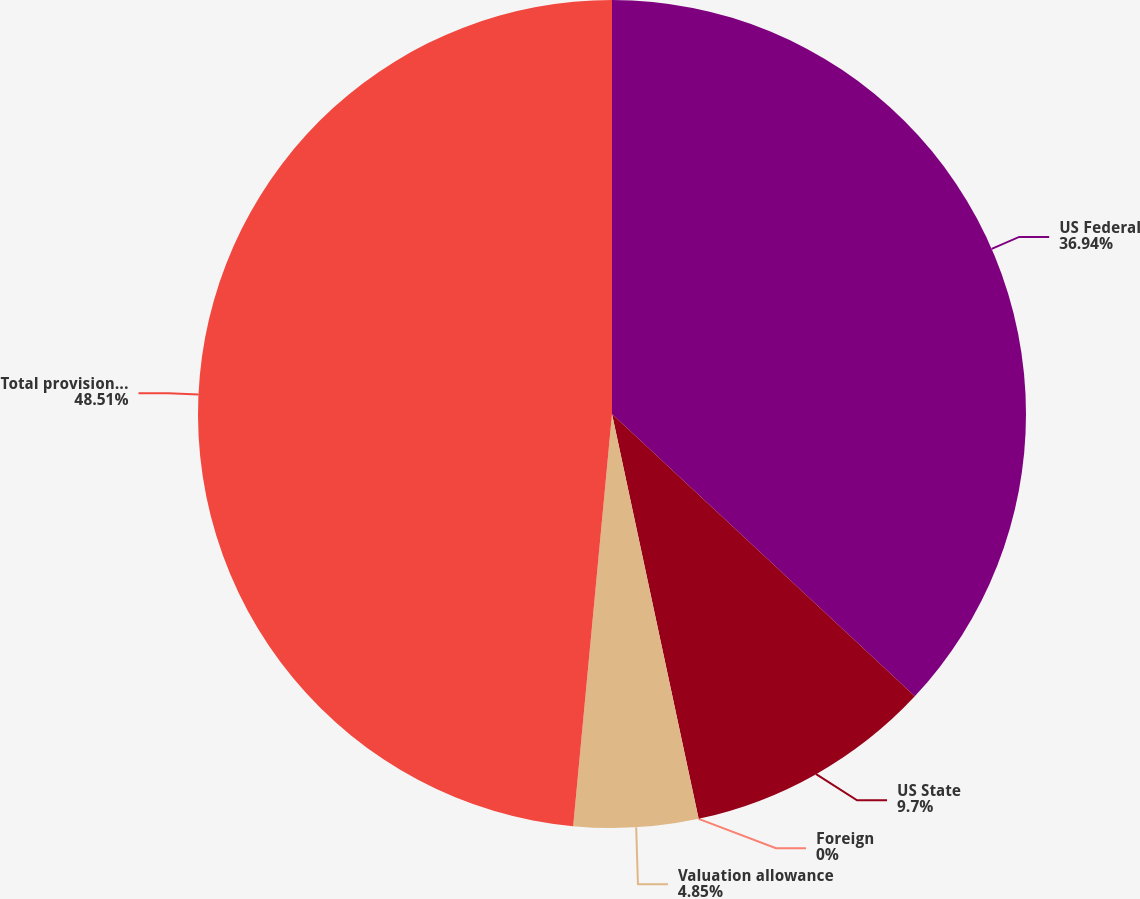<chart> <loc_0><loc_0><loc_500><loc_500><pie_chart><fcel>US Federal<fcel>US State<fcel>Foreign<fcel>Valuation allowance<fcel>Total provision for income<nl><fcel>36.94%<fcel>9.7%<fcel>0.0%<fcel>4.85%<fcel>48.5%<nl></chart> 